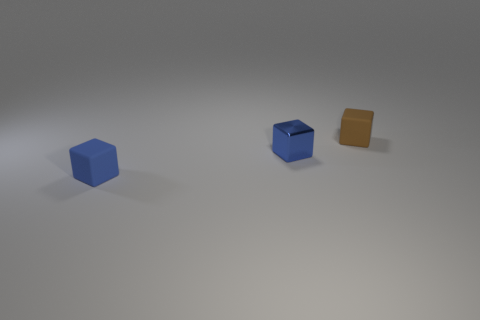Imagine these objects are part of a larger scene. What might that look like? Envisioning a wider context, these objects might be part of a minimalist art installation, displayed against a neutral backdrop to emphasize their colors and geometric shapes. Alternatively, they could be elements in a modern interior design setting, serving as bold accent pieces within a sleek and contemporary room. 